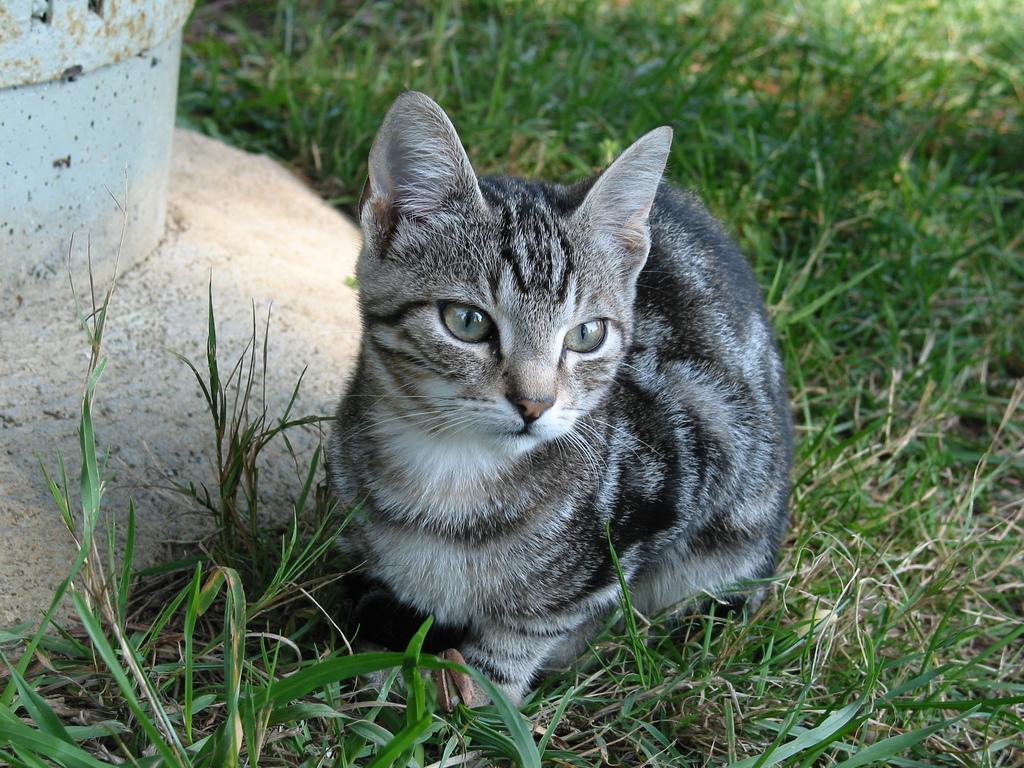In one or two sentences, can you explain what this image depicts? In this picture there is a white and black color cat sitting on the grass. Behind there is a white color pillar. 